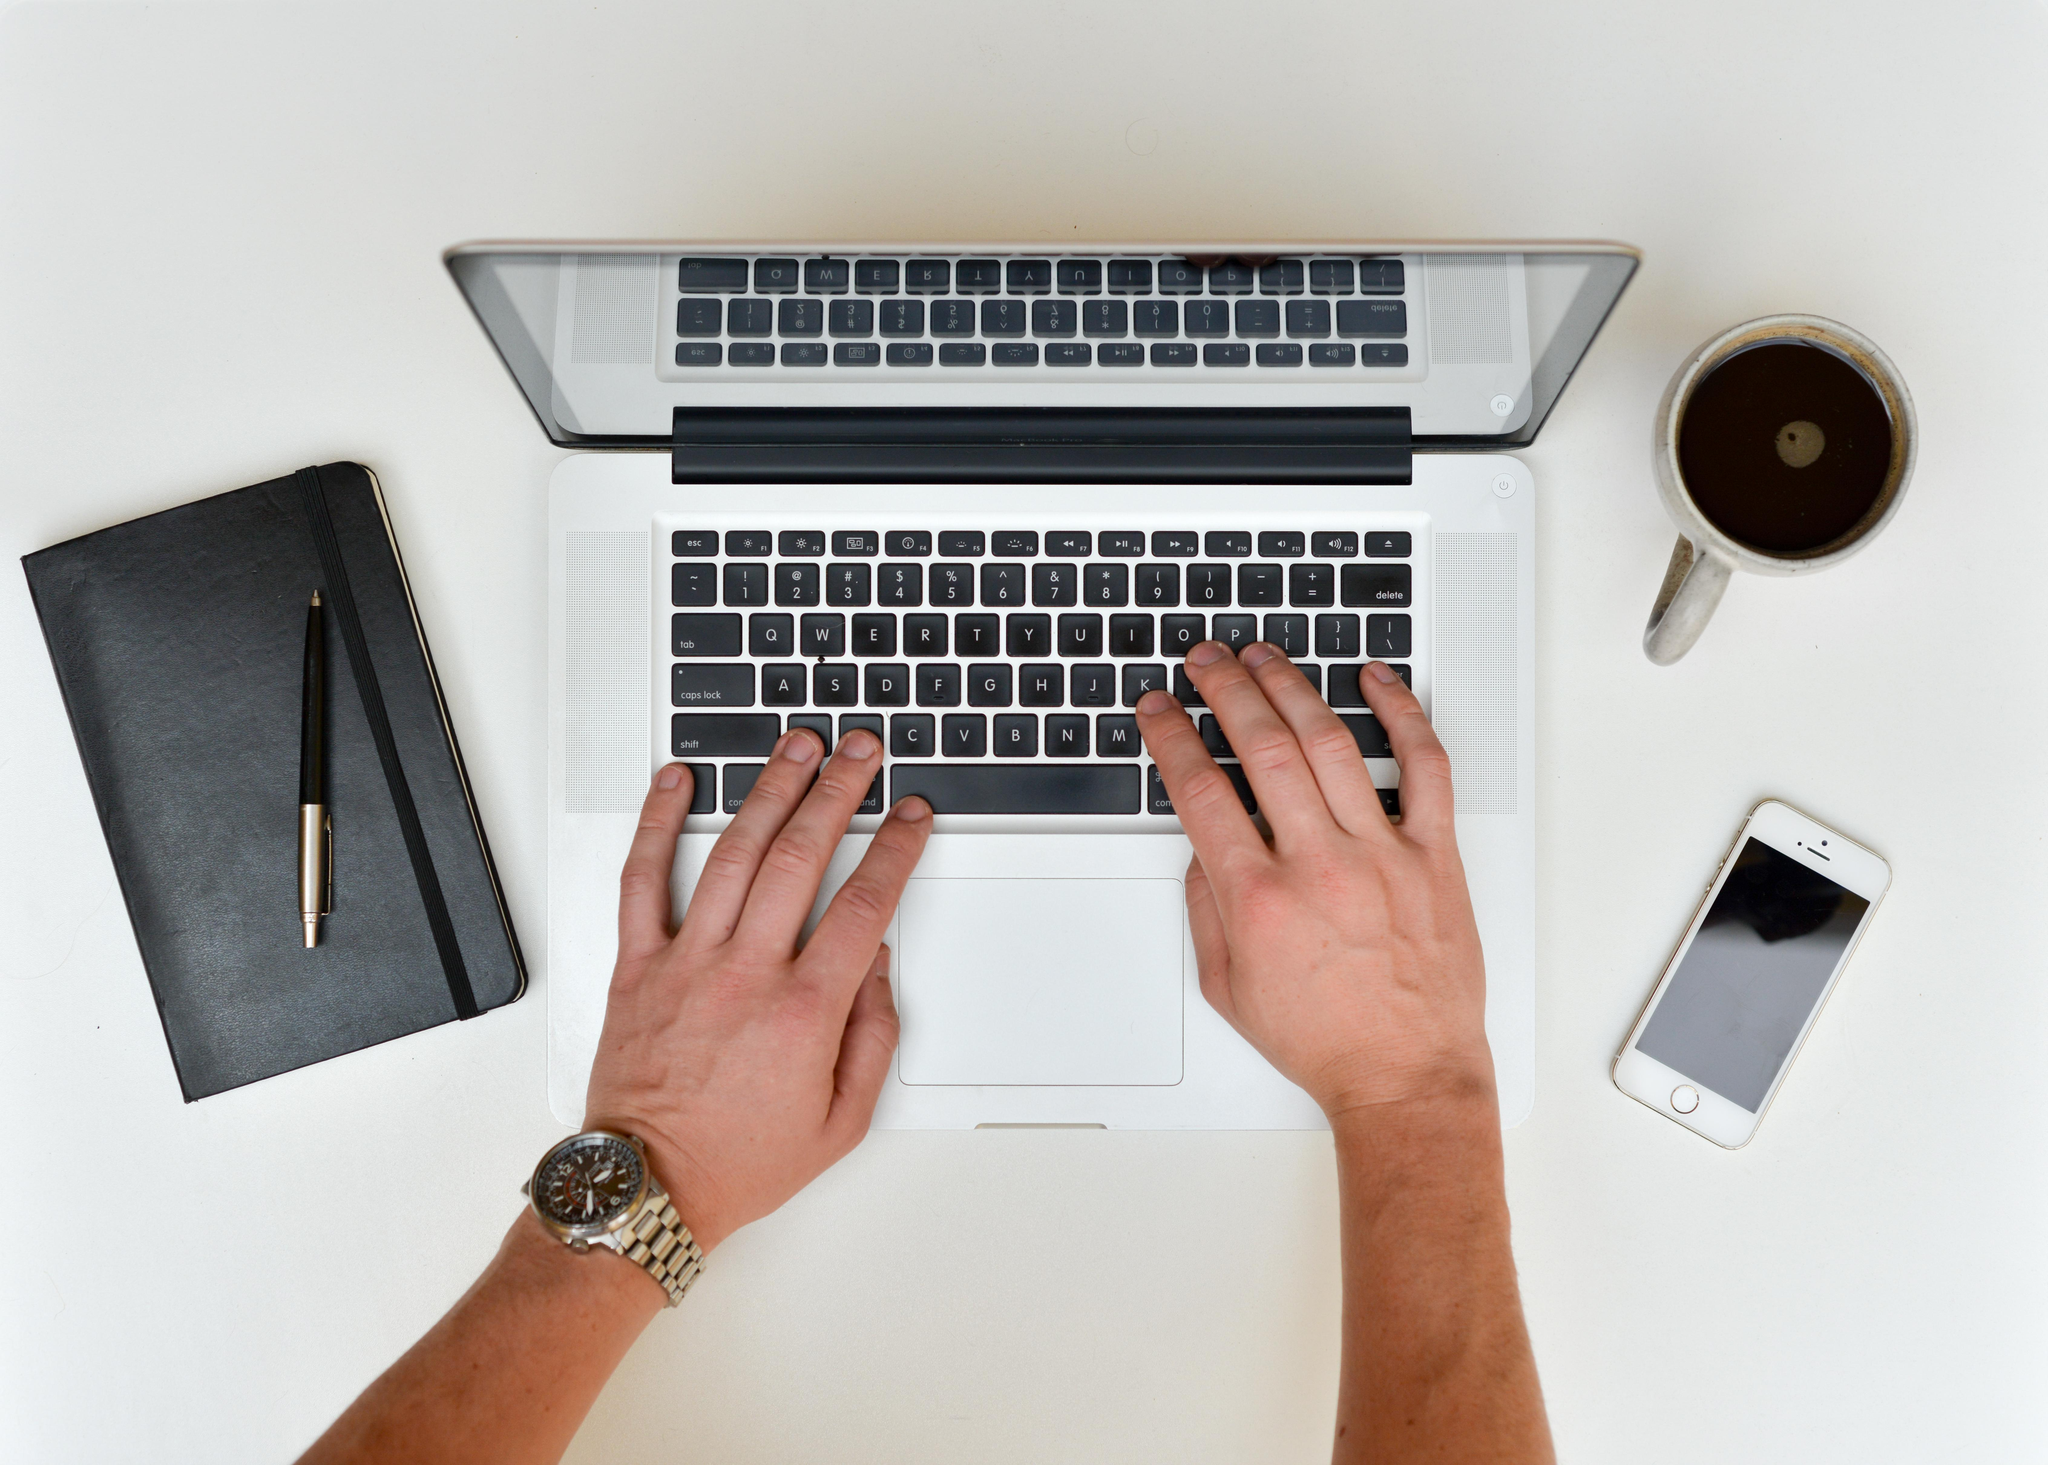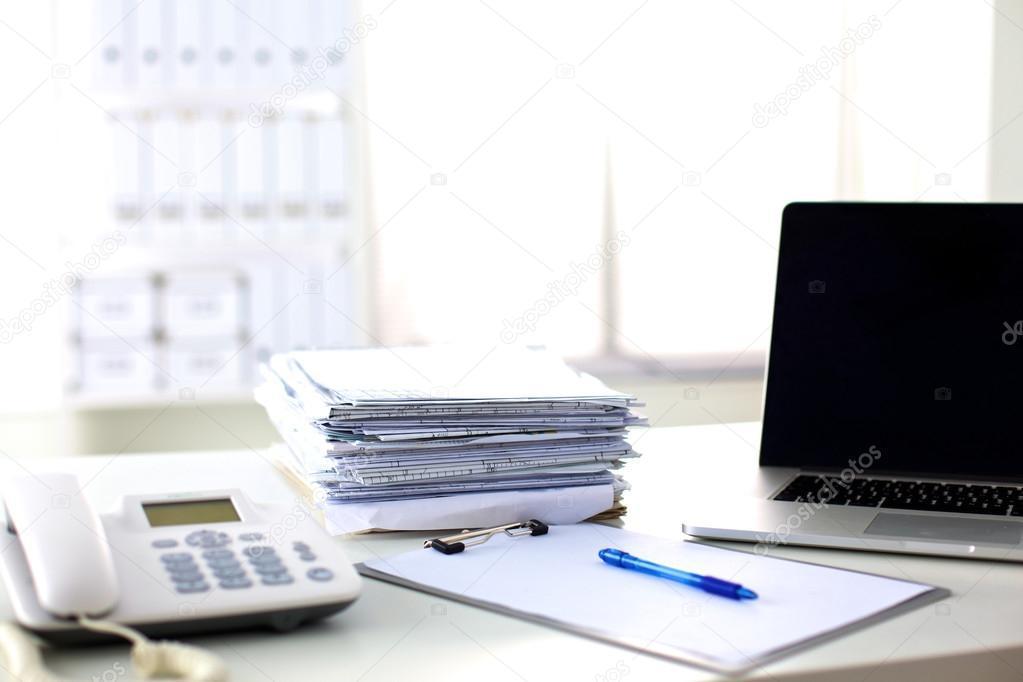The first image is the image on the left, the second image is the image on the right. Given the left and right images, does the statement "A pen is on flat paper by a laptop screen and stacked paper materials in the right image, and the left image includes at least one hand on the base of an open laptop." hold true? Answer yes or no. Yes. The first image is the image on the left, the second image is the image on the right. For the images displayed, is the sentence "There is one cup in the right image." factually correct? Answer yes or no. No. 